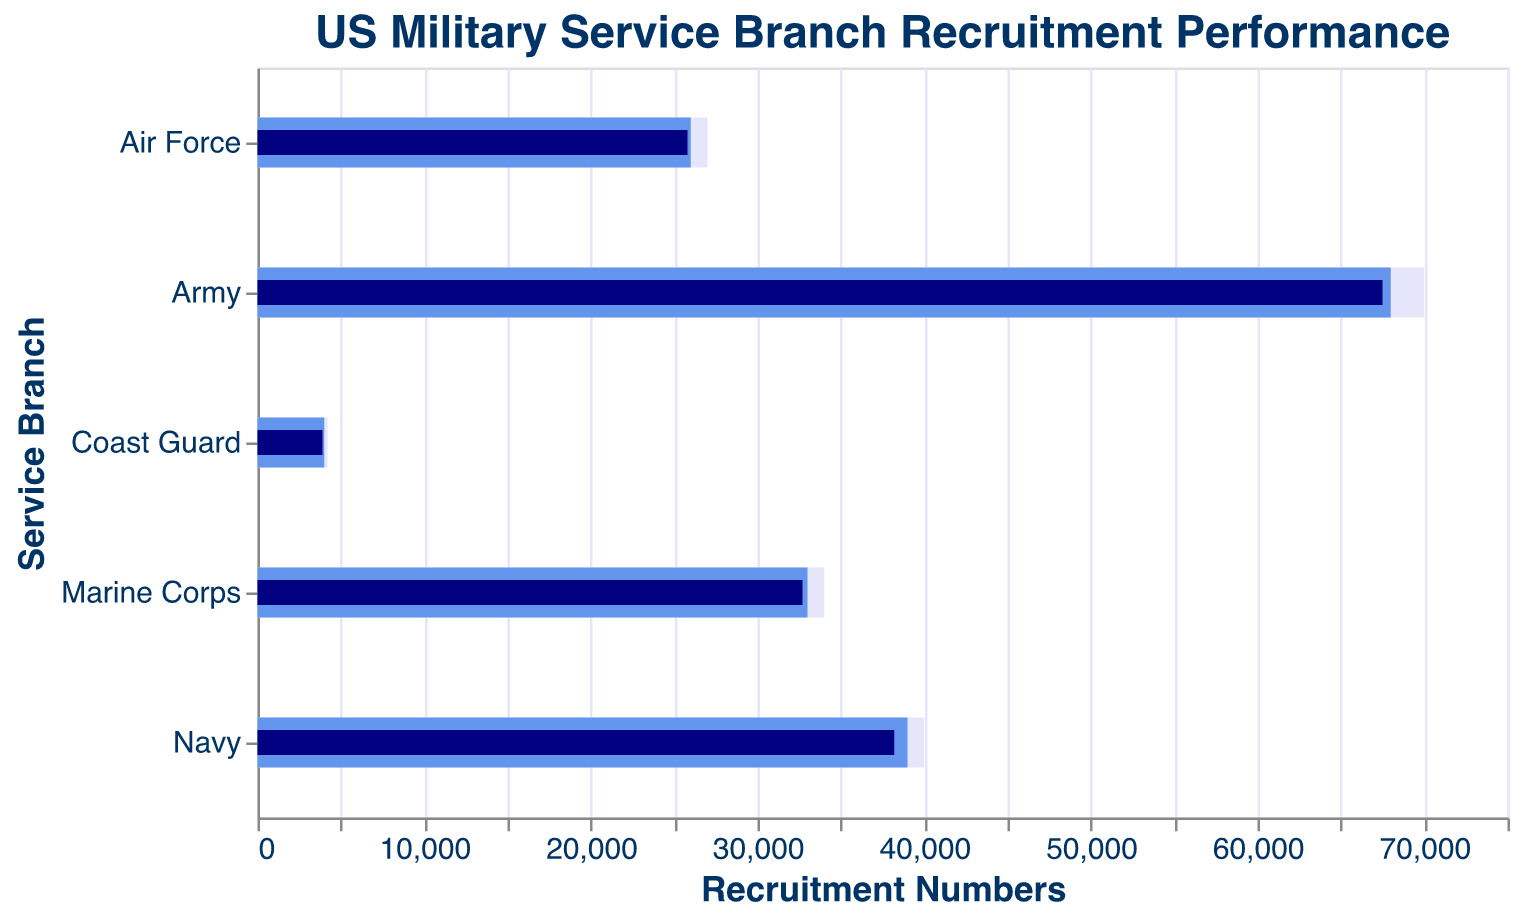What is the title of the figure? The title is prominently displayed at the top of the figure. It reads "US Military Service Branch Recruitment Performance" in font size 18 and color #003366.
Answer: US Military Service Branch Recruitment Performance How many service branches are represented in the figure? The y-axis lists five service branches, arranged by recruitment targets.
Answer: 5 Which branch had the highest recruitment target? By examining the bar heights on the figure's x-axis, the Army had the highest target at 68,000 recruits.
Answer: Army Which service branch narrowly missed its recruitment target by the smallest amount? To find the smallest difference between Target and Actual across the branches, we see the Marine Corps missed by 300 recruits (33,000 - 32,700).
Answer: Marine Corps How do the actual recruitment numbers of the Navy compare to its target? The Navy's target is 39,000, and the actual number is 38,200. This indicates an 800 recruit shortfall.
Answer: 800 recruits short What is the overall difference between the maximum recruitment number in the comparison data and the highest recruitment target among the branches? The highest recruitment comparison value is 70,000 (Army), and the highest target is also for the Army at 68,000, yielding a 2,000 difference.
Answer: 2,000 Which service branch exceeded its recruitment target by the largest margin? Comparison of the actual-actual recruitment values indicates the Coast Guard exceeded by 100 recruits (4,200 vs. 4,000).
Answer: Coast Guard Is the Army closer to its target or its comparison value? With an actual value of 67,500, the Army is 500 below its target (68,000) and 2,500 below its comparison value (70,000). Thus, it's closer to its target.
Answer: Closer to its target What color represents the actual recruitment numbers in the figure? The actual recruitment numbers are depicted in a darker blue color (#000080).
Answer: Dark blue Calculate the average comparison recruitment numbers for all service branches. Adding up all comparison values: 40,000 (Navy) + 70,000 (Army) + 27,000 (Air Force) + 34,000 (Marine Corps) + 4,200 (Coast Guard) = 175,200. Dividing by 5 branches gives an average comparison value of 35,040.
Answer: 35,040 